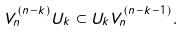<formula> <loc_0><loc_0><loc_500><loc_500>V _ { n } ^ { ( n - k ) } U _ { k } \subset U _ { k } V _ { n } ^ { ( n - k - 1 ) } .</formula> 